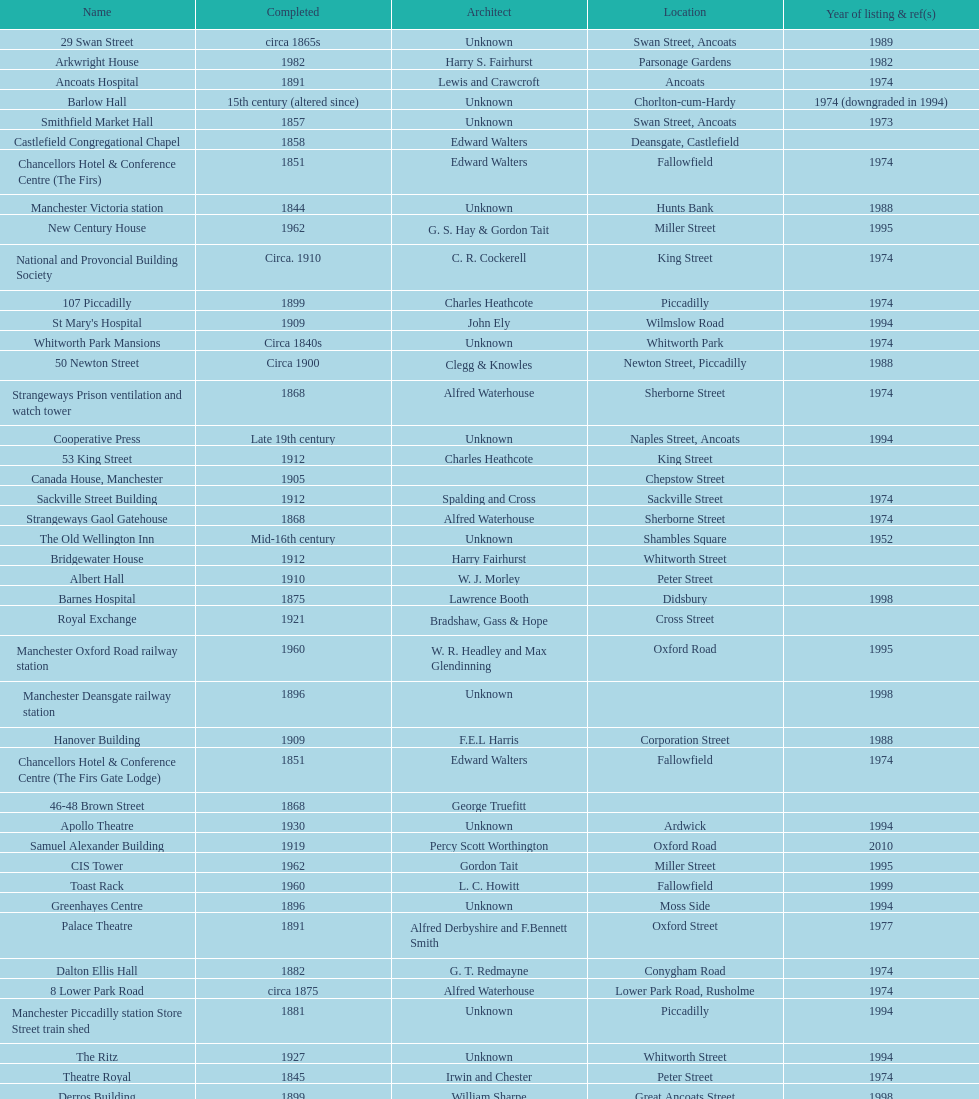During which year was the greatest quantity of buildings documented? 1974. 